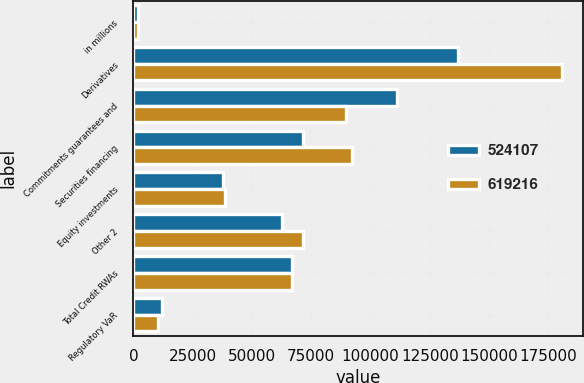Convert chart to OTSL. <chart><loc_0><loc_0><loc_500><loc_500><stacked_bar_chart><ecel><fcel>in millions<fcel>Derivatives<fcel>Commitments guarantees and<fcel>Securities financing<fcel>Equity investments<fcel>Other 2<fcel>Total Credit RWAs<fcel>Regulatory VaR<nl><fcel>524107<fcel>2015<fcel>136841<fcel>111391<fcel>71392<fcel>37687<fcel>62807<fcel>67099.5<fcel>12000<nl><fcel>619216<fcel>2014<fcel>180771<fcel>89783<fcel>92116<fcel>38526<fcel>71499<fcel>67099.5<fcel>10238<nl></chart> 